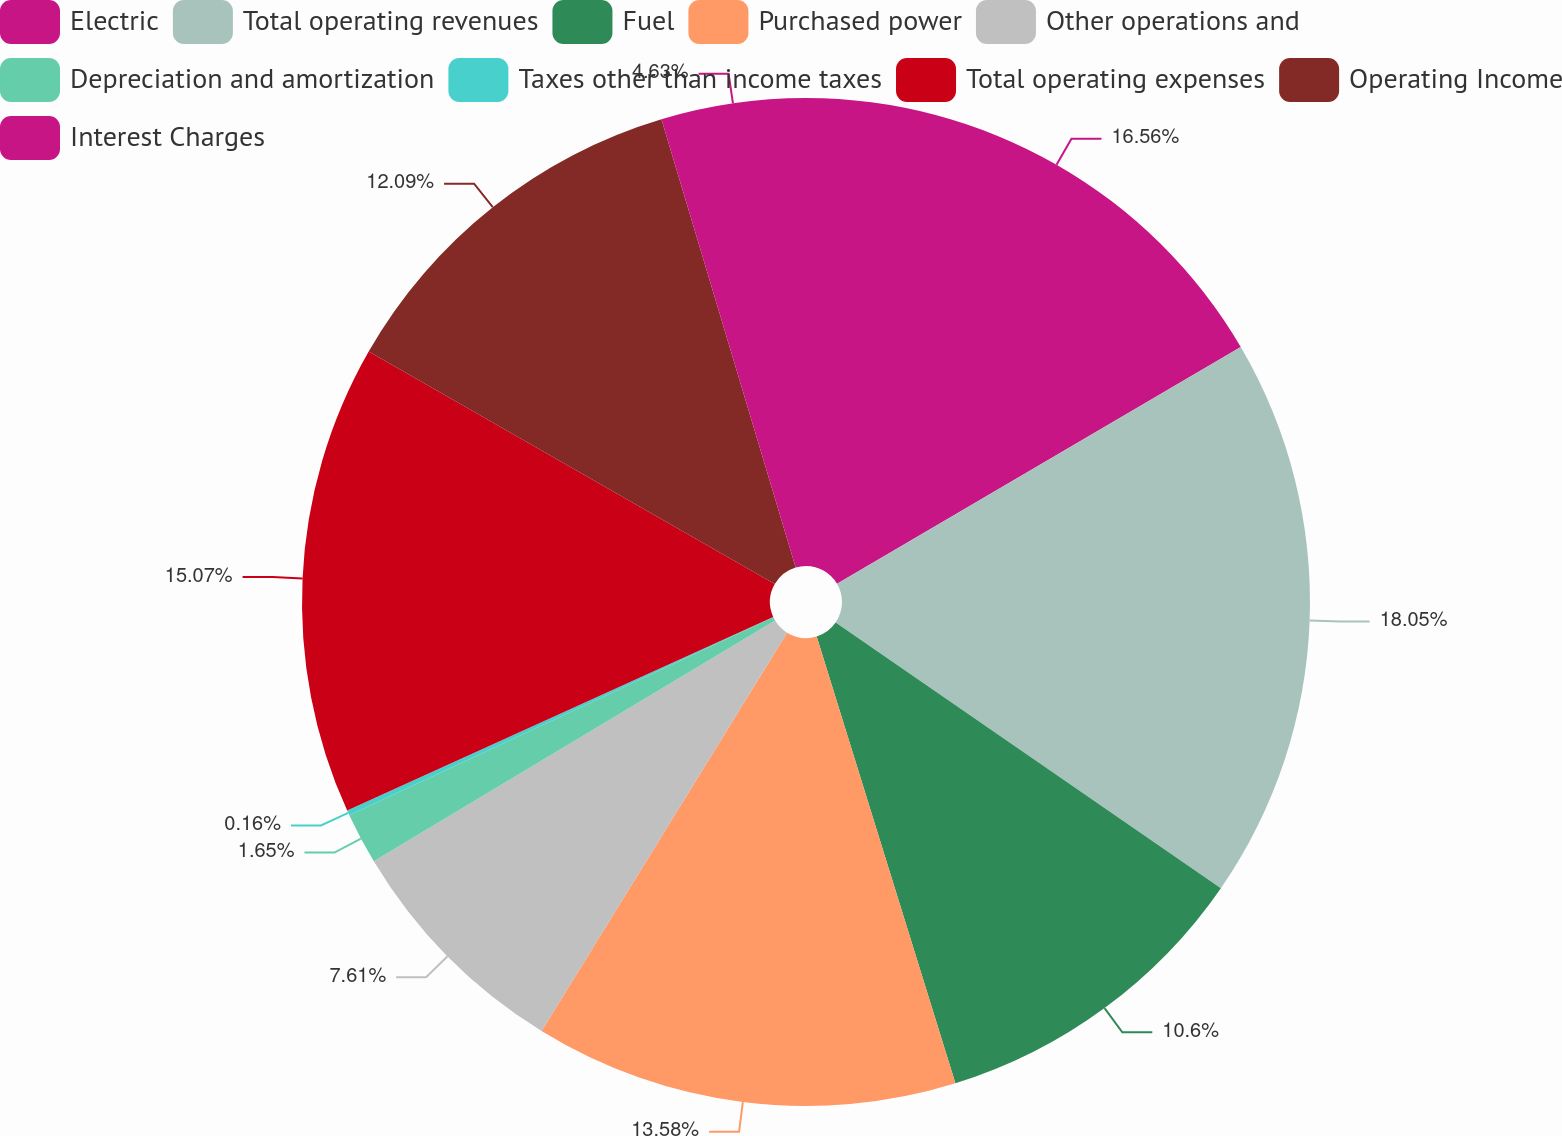Convert chart to OTSL. <chart><loc_0><loc_0><loc_500><loc_500><pie_chart><fcel>Electric<fcel>Total operating revenues<fcel>Fuel<fcel>Purchased power<fcel>Other operations and<fcel>Depreciation and amortization<fcel>Taxes other than income taxes<fcel>Total operating expenses<fcel>Operating Income<fcel>Interest Charges<nl><fcel>16.56%<fcel>18.05%<fcel>10.6%<fcel>13.58%<fcel>7.61%<fcel>1.65%<fcel>0.16%<fcel>15.07%<fcel>12.09%<fcel>4.63%<nl></chart> 